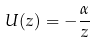Convert formula to latex. <formula><loc_0><loc_0><loc_500><loc_500>U ( z ) = - \frac { \alpha } { z }</formula> 